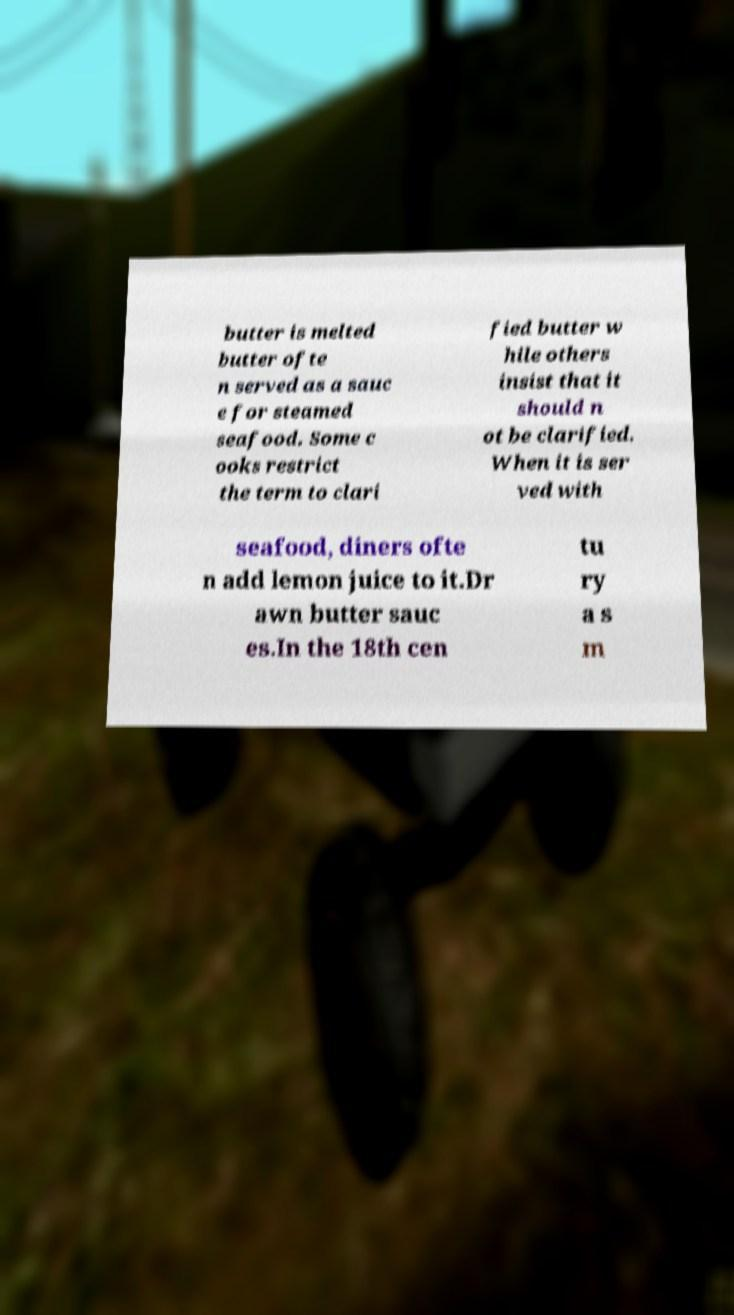I need the written content from this picture converted into text. Can you do that? butter is melted butter ofte n served as a sauc e for steamed seafood. Some c ooks restrict the term to clari fied butter w hile others insist that it should n ot be clarified. When it is ser ved with seafood, diners ofte n add lemon juice to it.Dr awn butter sauc es.In the 18th cen tu ry a s m 